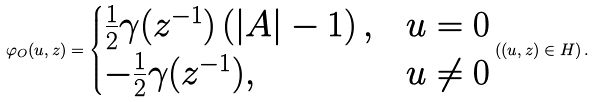<formula> <loc_0><loc_0><loc_500><loc_500>\varphi _ { O } ( u , z ) = \begin{cases} \frac { 1 } { 2 } \gamma ( z ^ { - 1 } ) \left ( | A | - 1 \right ) , & u = 0 \\ - \frac { 1 } { 2 } \gamma ( z ^ { - 1 } ) , & u \neq 0 \end{cases} \left ( ( u , z ) \in H \right ) .</formula> 